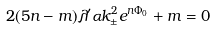Convert formula to latex. <formula><loc_0><loc_0><loc_500><loc_500>2 ( 5 n - m ) \lambda ^ { \prime } \alpha k _ { \pm } ^ { 2 } e ^ { n \Phi _ { 0 } } + m = 0</formula> 